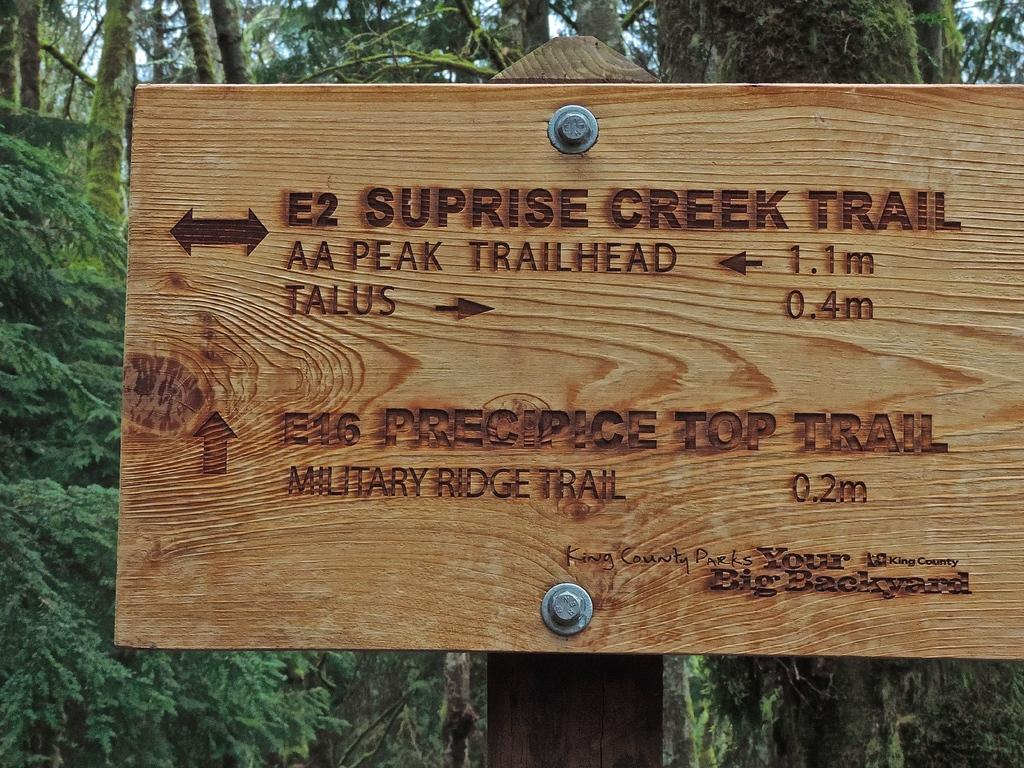What is written on the wooden board in the image? There is text on a wooden board in the image. What can be seen besides the wooden board in the image? There is a pole and bolts visible in the image. What is visible in the background of the image? There are trees visible in the background of the image. How many bones are present in the image? There are no bones present in the image. What type of paste is being used to hold the wooden board in place? There is no paste visible in the image, and the wooden board is not being held in place. 